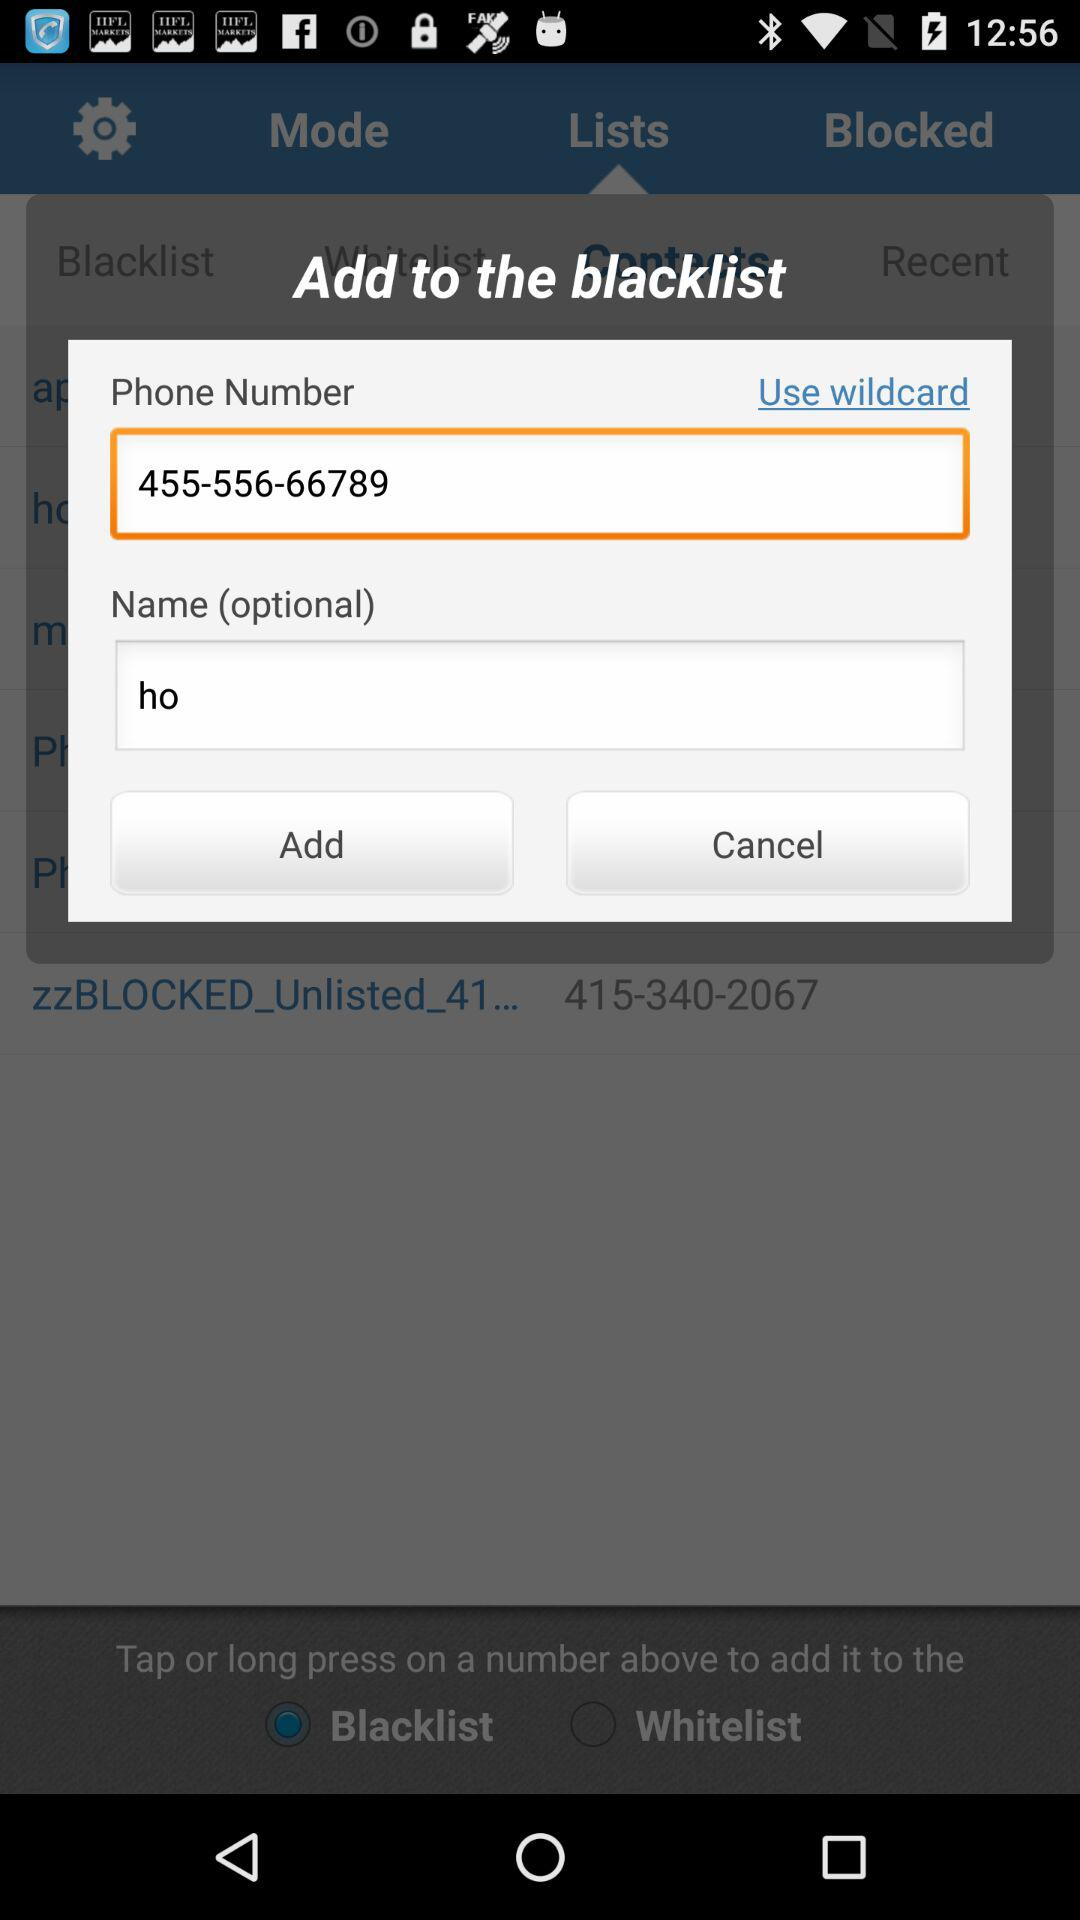What's the name? The name is "ho". 